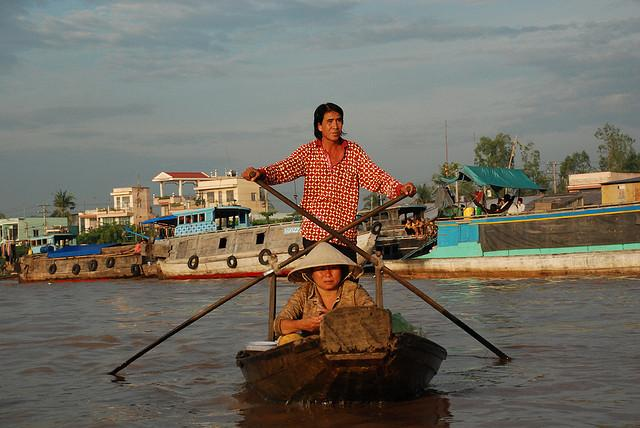What shape are the oars forming?

Choices:
A) cross
B) star
C) circle
D) square cross 